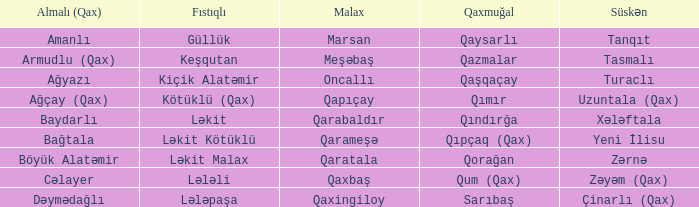What is the Almali village with the Malax village qaxingiloy? Dəymədağlı. 